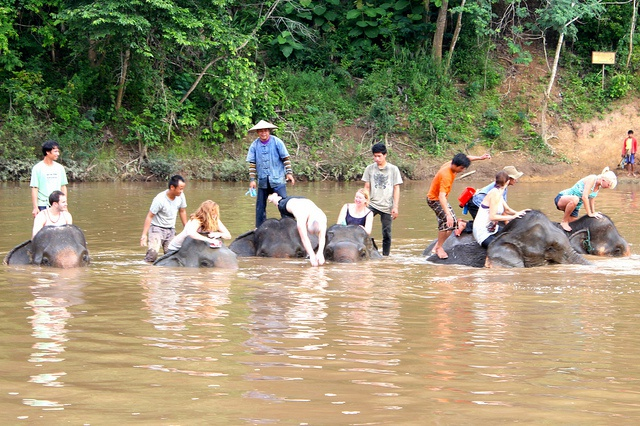Describe the objects in this image and their specific colors. I can see elephant in darkgreen, gray, darkgray, tan, and lightgray tones, people in darkgreen, darkgray, lightblue, navy, and white tones, elephant in darkgreen, darkgray, gray, and tan tones, people in darkgreen, lightgray, darkgray, black, and gray tones, and people in darkgreen, white, darkgray, lightpink, and gray tones in this image. 